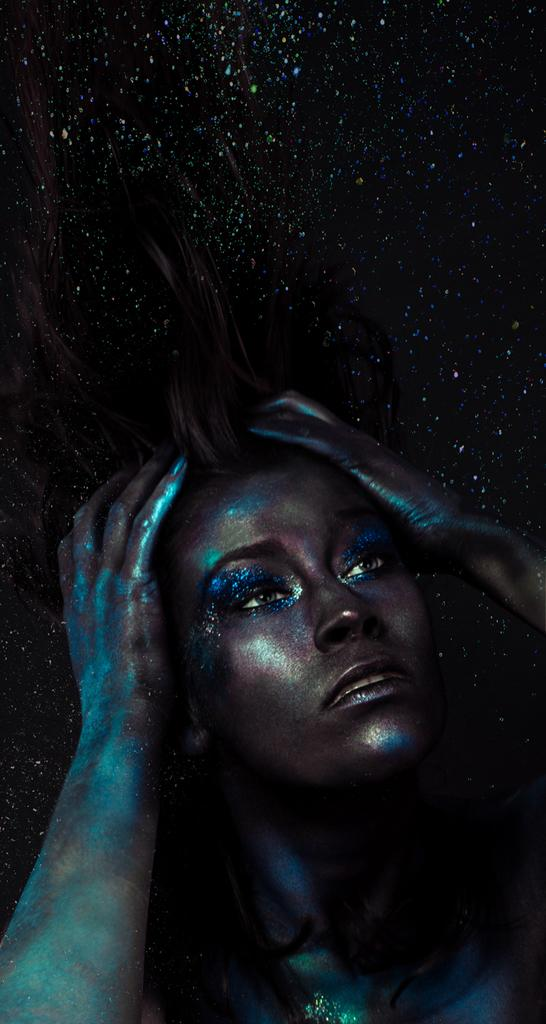Who is the main subject in the image? There is a woman in the image. What is unique about the woman's appearance? The woman's body is painted with something shiny. What can be seen in the sky at the top of the image? There are stars visible in the sky at the top of the image. What type of plate is the woman holding in the image? There is no plate present in the image. Who is the manager of the event in the image? There is no event or manager mentioned in the image. 